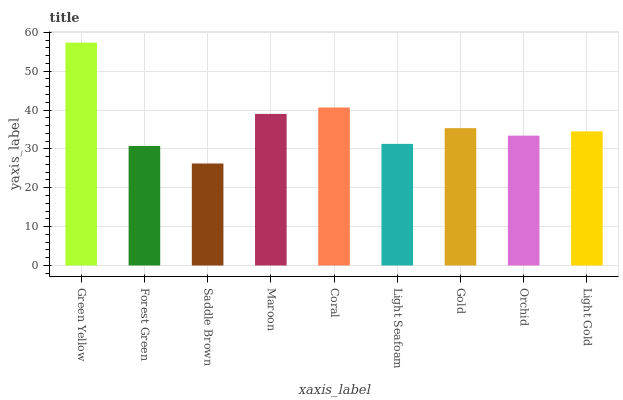Is Forest Green the minimum?
Answer yes or no. No. Is Forest Green the maximum?
Answer yes or no. No. Is Green Yellow greater than Forest Green?
Answer yes or no. Yes. Is Forest Green less than Green Yellow?
Answer yes or no. Yes. Is Forest Green greater than Green Yellow?
Answer yes or no. No. Is Green Yellow less than Forest Green?
Answer yes or no. No. Is Light Gold the high median?
Answer yes or no. Yes. Is Light Gold the low median?
Answer yes or no. Yes. Is Green Yellow the high median?
Answer yes or no. No. Is Green Yellow the low median?
Answer yes or no. No. 